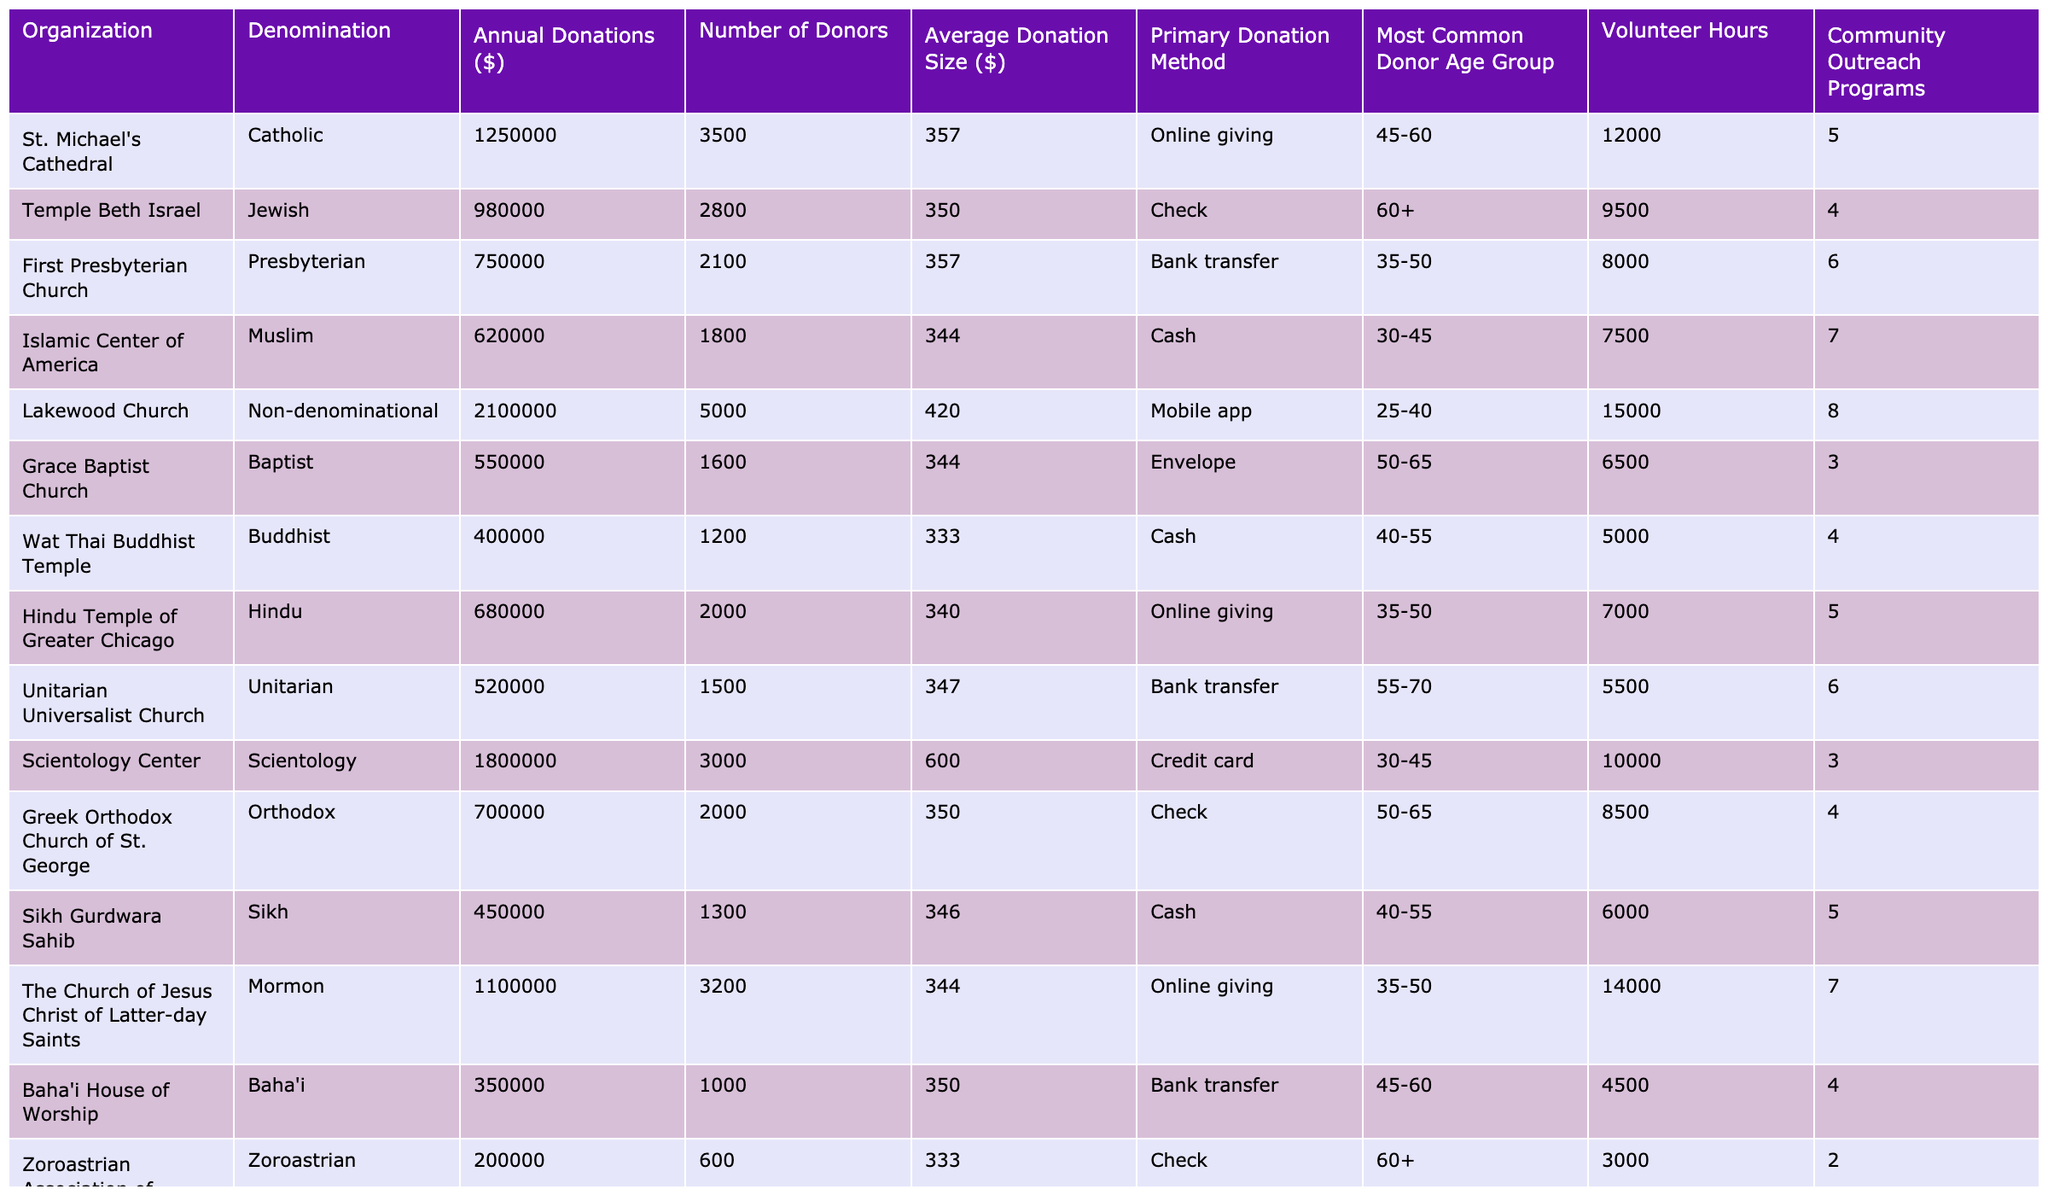What is the organization with the highest annual donations? By examining the "Annual Donations ($)" column, we can see that Lakewood Church has the highest figure at $2,100,000.
Answer: Lakewood Church How many volunteers did St. Michael's Cathedral have? Looking at the "Volunteer Hours" column for St. Michael's Cathedral, the value is 12,000 hours.
Answer: 12000 What is the average donation size for the Islamic Center of America? The "Average Donation Size ($)" for the Islamic Center of America is 344, as directly mentioned in the table.
Answer: 344 Which organization has the fewest number of donors? The "Number of Donors" column indicates that the Zoroastrian Association of Greater Chicago has the fewest donors at 600.
Answer: 600 What is the total amount of donations received by Christian organizations? Summing the annual donations for the organizations classified as Christian: $1,250,000 (Catholic) + $750,000 (Presbyterian) + $550,000 (Baptist) + $1,100,000 (Mormon), gives $3,650,000.
Answer: 3650000 Is there any organization that primarily accepts donations through cash? The table shows that the Islamic Center of America and the Sikh Gurdwara Sahib both list "Cash" as their primary donation method, indicating the answer is yes.
Answer: Yes Which organization received more than $1 million in donations but has fewer than 3,000 donors? The Church of Jesus Christ of Latter-day Saints received $1,100,000 with exactly 3,200 donors, while Scientology Center was the only one over $1 million with exactly 3,000 donors, indicating no organizations meet these criteria.
Answer: None What is the average donation size across all organizations? To find the average donation size, we sum all the average donation sizes \((357 + 350 + 357 + 344 + 420 + 344 + 333 + 340 + 347 + 600 + 350 + 333)\) giving 4,136 and then divide by the number of organizations, which is 12. Thus, \(4,136 / 12 = 344.67\), approximately 345.
Answer: 345 Which organization has the most community outreach programs? Referring to the "Community Outreach Programs" column, Lakewood Church has the most, with 8 programs running.
Answer: Lakewood Church What percentage of the total donations does the Grace Baptist Church's donations represent? First, we find the total donations: $7,000,000; then the percentage for Grace Baptist Church is \((550,000 / 7,000,000) \times 100\) which equals approximately 7.86%.
Answer: 7.86% 